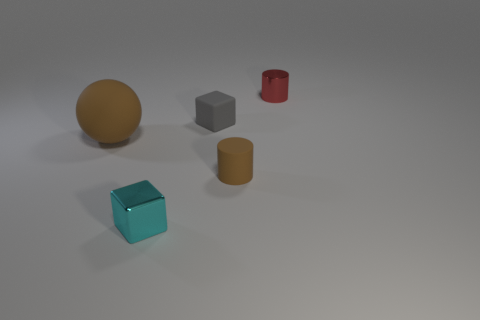What shape is the tiny cyan object that is the same material as the red thing?
Offer a very short reply. Cube. Is there anything else of the same color as the rubber cylinder?
Offer a terse response. Yes. How many balls are there?
Keep it short and to the point. 1. There is a cylinder that is in front of the shiny thing right of the tiny cyan metal cube; what is it made of?
Ensure brevity in your answer.  Rubber. There is a block that is behind the big object that is on the left side of the tiny block that is in front of the ball; what color is it?
Give a very brief answer. Gray. Do the metallic cylinder and the matte cylinder have the same color?
Give a very brief answer. No. How many gray rubber balls are the same size as the red metal cylinder?
Offer a terse response. 0. Is the number of tiny rubber cubes left of the big brown matte ball greater than the number of brown matte spheres that are to the left of the cyan thing?
Offer a very short reply. No. There is a cylinder to the right of the cylinder in front of the gray cube; what color is it?
Your answer should be very brief. Red. Are the brown cylinder and the cyan block made of the same material?
Your answer should be very brief. No. 